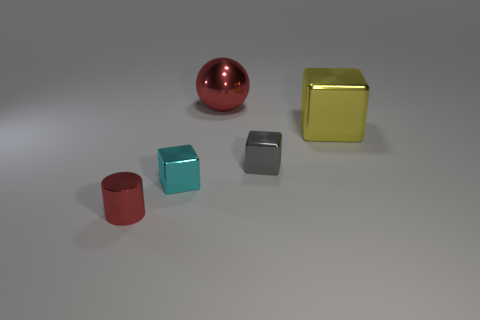Does the tiny cyan thing have the same shape as the red thing behind the metal cylinder?
Keep it short and to the point. No. What material is the large red object?
Offer a terse response. Metal. What is the color of the block left of the red object behind the red metal thing that is in front of the red shiny ball?
Your response must be concise. Cyan. There is another small thing that is the same shape as the cyan object; what is its material?
Your answer should be compact. Metal. How many other yellow things are the same size as the yellow shiny object?
Keep it short and to the point. 0. What number of big yellow metallic blocks are there?
Keep it short and to the point. 1. Is the material of the cylinder the same as the red thing on the right side of the small red cylinder?
Provide a succinct answer. Yes. What number of cyan things are shiny cylinders or large cubes?
Your response must be concise. 0. There is a gray block that is made of the same material as the big yellow object; what is its size?
Provide a short and direct response. Small. What number of other gray things are the same shape as the gray object?
Your answer should be compact. 0. 